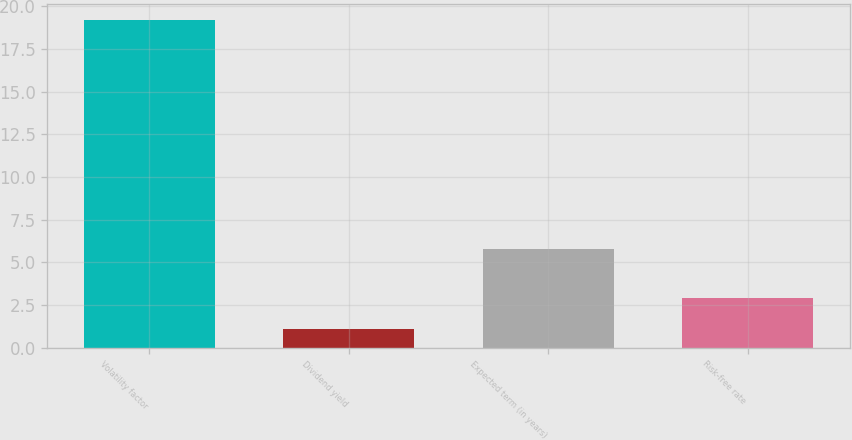Convert chart to OTSL. <chart><loc_0><loc_0><loc_500><loc_500><bar_chart><fcel>Volatility factor<fcel>Dividend yield<fcel>Expected term (in years)<fcel>Risk-free rate<nl><fcel>19.2<fcel>1.1<fcel>5.78<fcel>2.91<nl></chart> 